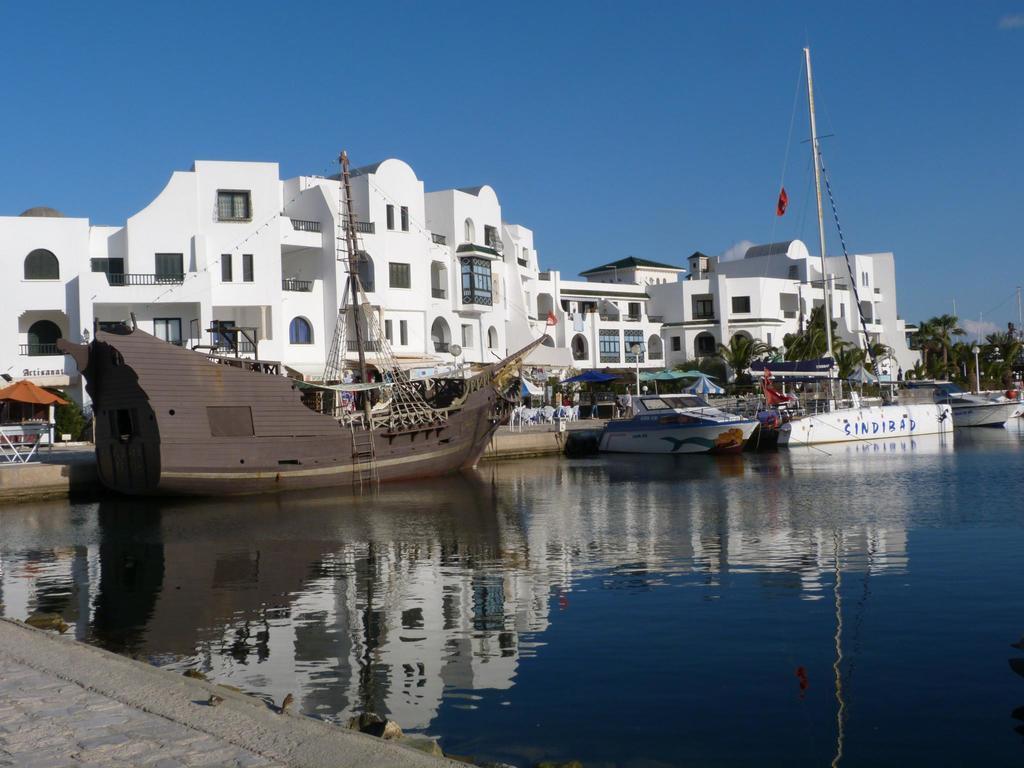Describe this image in one or two sentences. In the middle of the image we can see the buildings, boats, poles, tents, chairs, trees are present. At the bottom of the image water is there. At the top of the image sky is present. At the bottom left corner floor is there. 